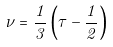Convert formula to latex. <formula><loc_0><loc_0><loc_500><loc_500>\nu = \frac { 1 } { 3 } \left ( \tau - \frac { 1 } { 2 } \right )</formula> 